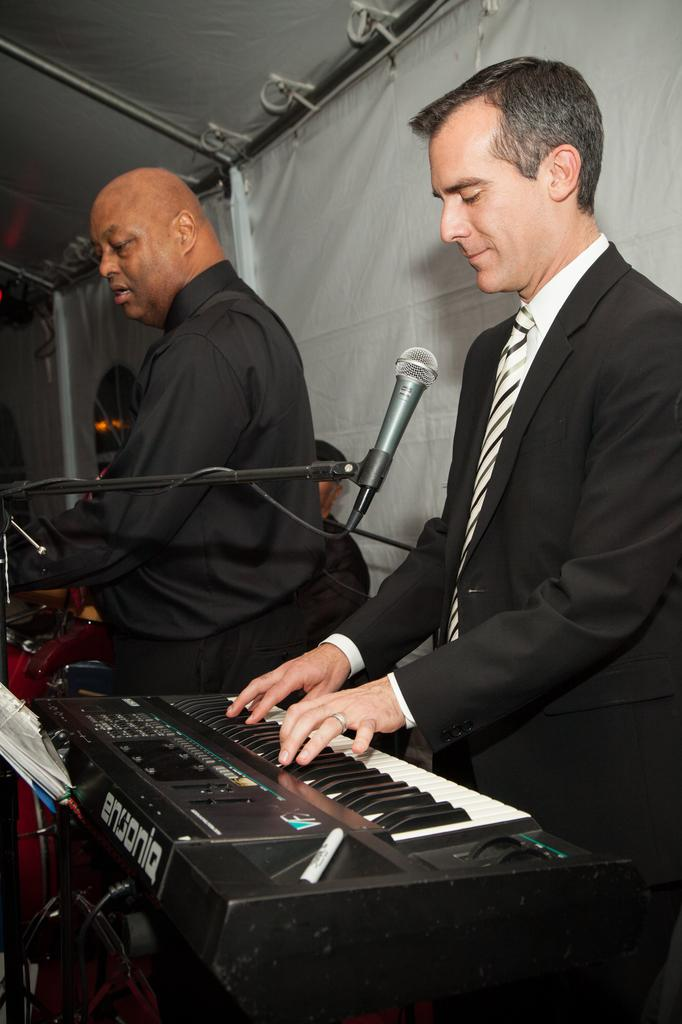What is the man in the image doing? The man is playing a piano. What is the man wearing in the image? The man is wearing a blazer and tie. Who is standing nearby the man? There is a person standing nearby, and they are holding a microphone. What can be seen in the background of the image? There is a tent with cloth in the background of the image. What type of lace can be seen on the man's clothing in the image? There is no lace visible on the man's clothing in the image; he is wearing a blazer and tie. At what angle is the airport visible in the image? There is no airport present in the image. 